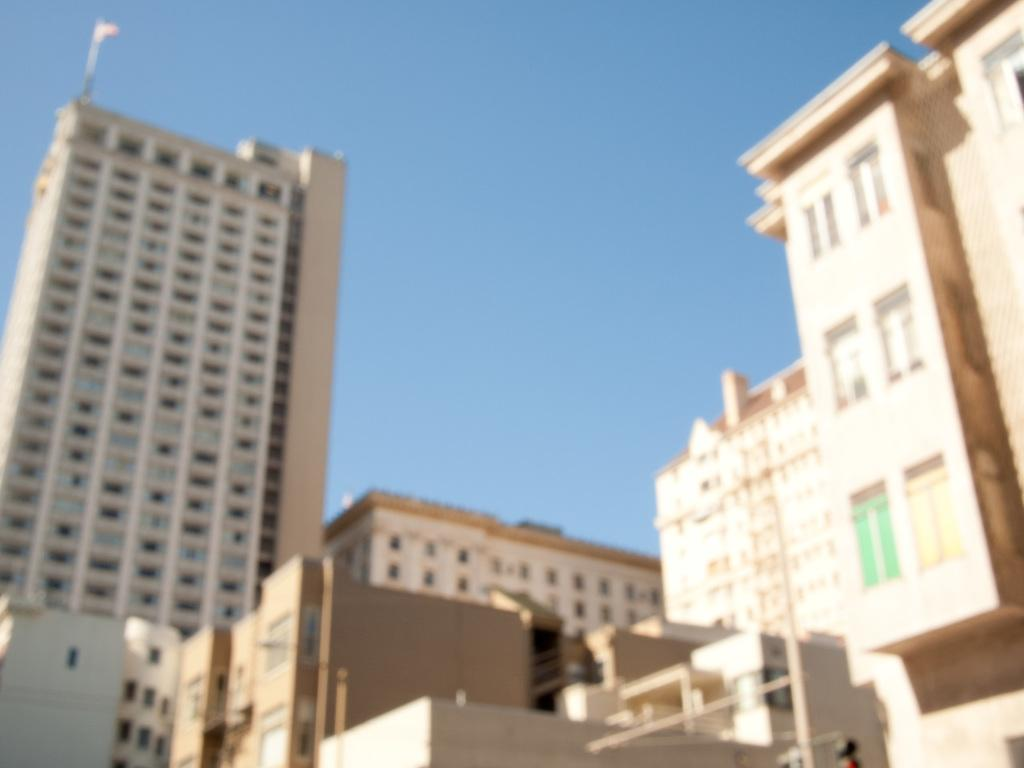What type of structures can be seen in the image? There are buildings in the image. How are the tomatoes being sorted in the image? There are no tomatoes present in the image, so they cannot be sorted. 